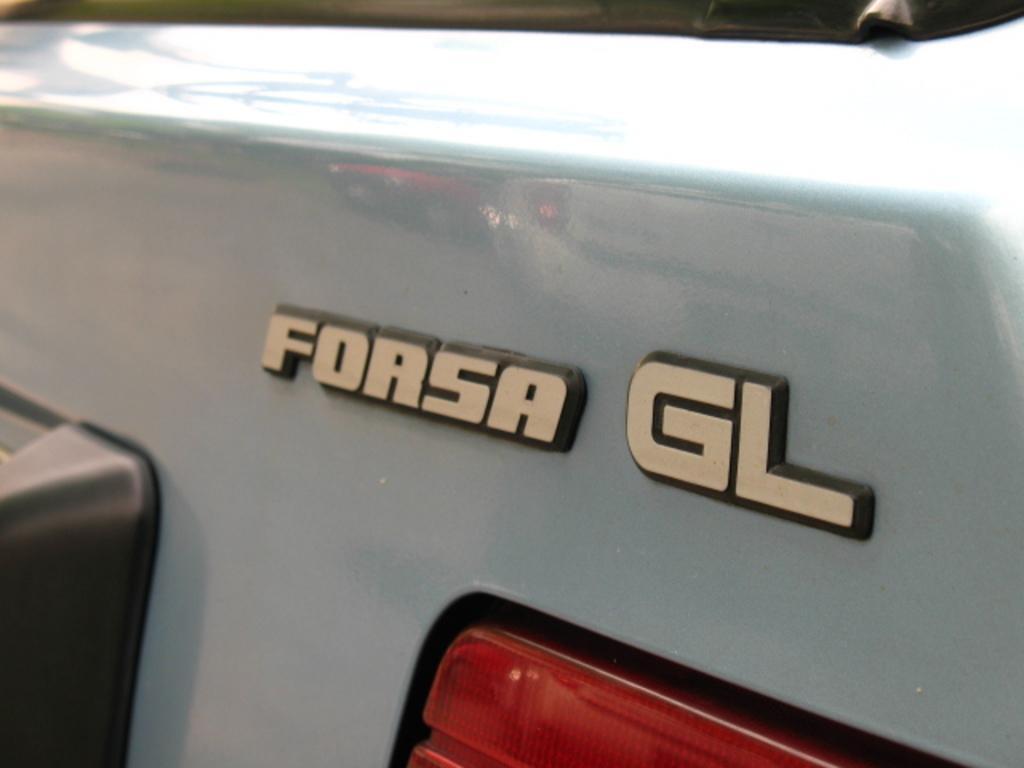Please provide a concise description of this image. In this image there is a vehicle with a headlight and there is a text on the vehicle. 